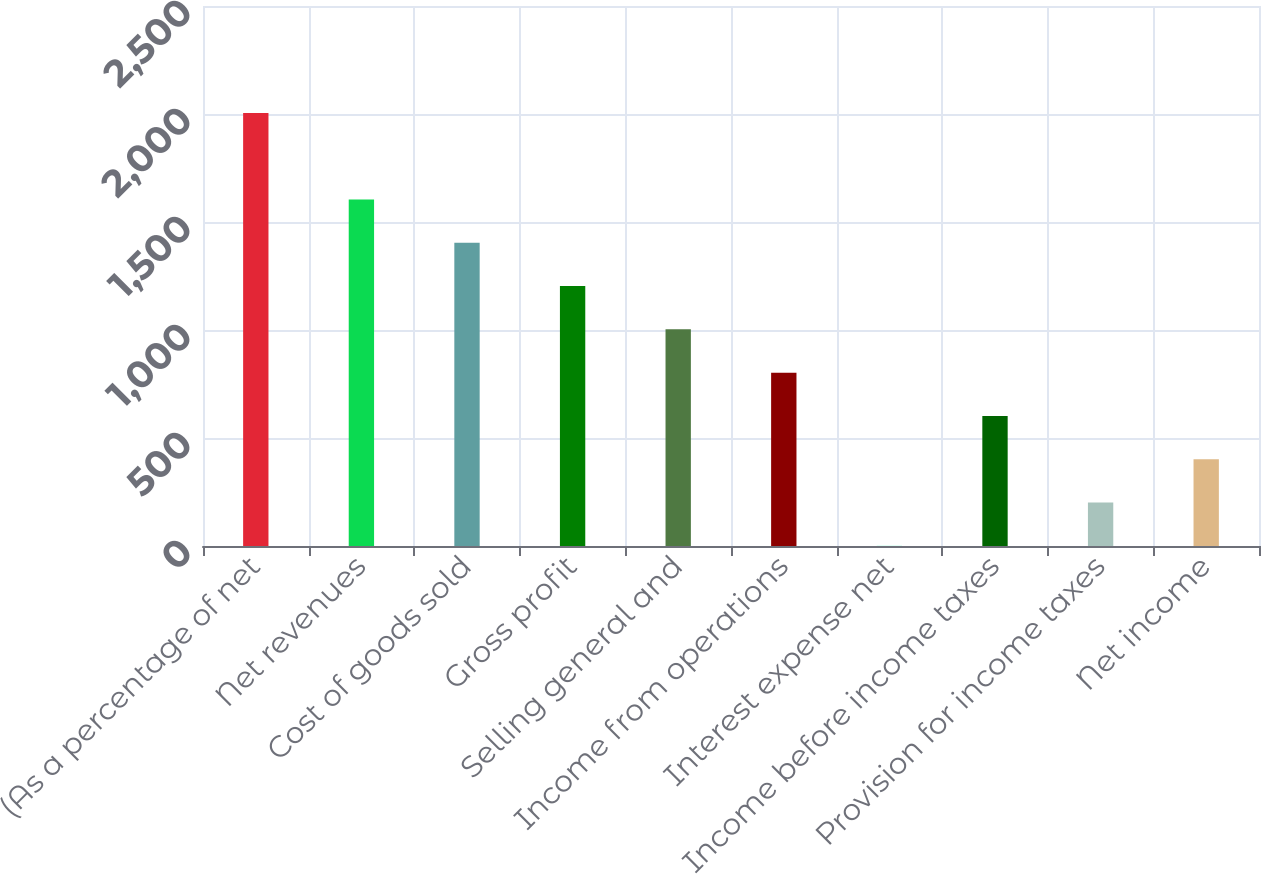Convert chart to OTSL. <chart><loc_0><loc_0><loc_500><loc_500><bar_chart><fcel>(As a percentage of net<fcel>Net revenues<fcel>Cost of goods sold<fcel>Gross profit<fcel>Selling general and<fcel>Income from operations<fcel>Interest expense net<fcel>Income before income taxes<fcel>Provision for income taxes<fcel>Net income<nl><fcel>2005<fcel>1604.2<fcel>1403.8<fcel>1203.4<fcel>1003<fcel>802.6<fcel>1<fcel>602.2<fcel>201.4<fcel>401.8<nl></chart> 